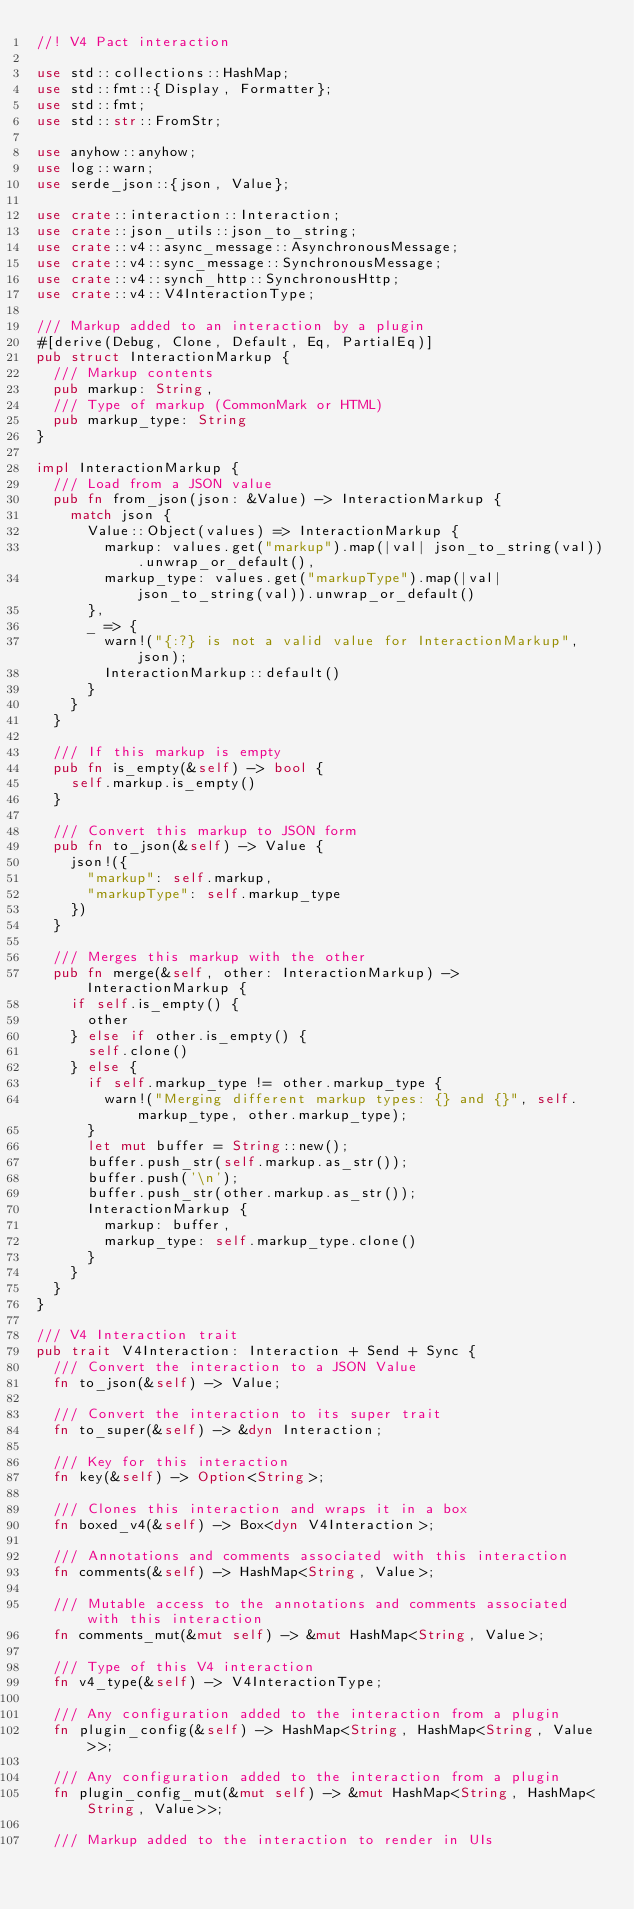Convert code to text. <code><loc_0><loc_0><loc_500><loc_500><_Rust_>//! V4 Pact interaction

use std::collections::HashMap;
use std::fmt::{Display, Formatter};
use std::fmt;
use std::str::FromStr;

use anyhow::anyhow;
use log::warn;
use serde_json::{json, Value};

use crate::interaction::Interaction;
use crate::json_utils::json_to_string;
use crate::v4::async_message::AsynchronousMessage;
use crate::v4::sync_message::SynchronousMessage;
use crate::v4::synch_http::SynchronousHttp;
use crate::v4::V4InteractionType;

/// Markup added to an interaction by a plugin
#[derive(Debug, Clone, Default, Eq, PartialEq)]
pub struct InteractionMarkup {
  /// Markup contents
  pub markup: String,
  /// Type of markup (CommonMark or HTML)
  pub markup_type: String
}

impl InteractionMarkup {
  /// Load from a JSON value
  pub fn from_json(json: &Value) -> InteractionMarkup {
    match json {
      Value::Object(values) => InteractionMarkup {
        markup: values.get("markup").map(|val| json_to_string(val)).unwrap_or_default(),
        markup_type: values.get("markupType").map(|val| json_to_string(val)).unwrap_or_default()
      },
      _ => {
        warn!("{:?} is not a valid value for InteractionMarkup", json);
        InteractionMarkup::default()
      }
    }
  }

  /// If this markup is empty
  pub fn is_empty(&self) -> bool {
    self.markup.is_empty()
  }

  /// Convert this markup to JSON form
  pub fn to_json(&self) -> Value {
    json!({
      "markup": self.markup,
      "markupType": self.markup_type
    })
  }

  /// Merges this markup with the other
  pub fn merge(&self, other: InteractionMarkup) -> InteractionMarkup {
    if self.is_empty() {
      other
    } else if other.is_empty() {
      self.clone()
    } else {
      if self.markup_type != other.markup_type {
        warn!("Merging different markup types: {} and {}", self.markup_type, other.markup_type);
      }
      let mut buffer = String::new();
      buffer.push_str(self.markup.as_str());
      buffer.push('\n');
      buffer.push_str(other.markup.as_str());
      InteractionMarkup {
        markup: buffer,
        markup_type: self.markup_type.clone()
      }
    }
  }
}

/// V4 Interaction trait
pub trait V4Interaction: Interaction + Send + Sync {
  /// Convert the interaction to a JSON Value
  fn to_json(&self) -> Value;

  /// Convert the interaction to its super trait
  fn to_super(&self) -> &dyn Interaction;

  /// Key for this interaction
  fn key(&self) -> Option<String>;

  /// Clones this interaction and wraps it in a box
  fn boxed_v4(&self) -> Box<dyn V4Interaction>;

  /// Annotations and comments associated with this interaction
  fn comments(&self) -> HashMap<String, Value>;

  /// Mutable access to the annotations and comments associated with this interaction
  fn comments_mut(&mut self) -> &mut HashMap<String, Value>;

  /// Type of this V4 interaction
  fn v4_type(&self) -> V4InteractionType;

  /// Any configuration added to the interaction from a plugin
  fn plugin_config(&self) -> HashMap<String, HashMap<String, Value>>;

  /// Any configuration added to the interaction from a plugin
  fn plugin_config_mut(&mut self) -> &mut HashMap<String, HashMap<String, Value>>;

  /// Markup added to the interaction to render in UIs</code> 